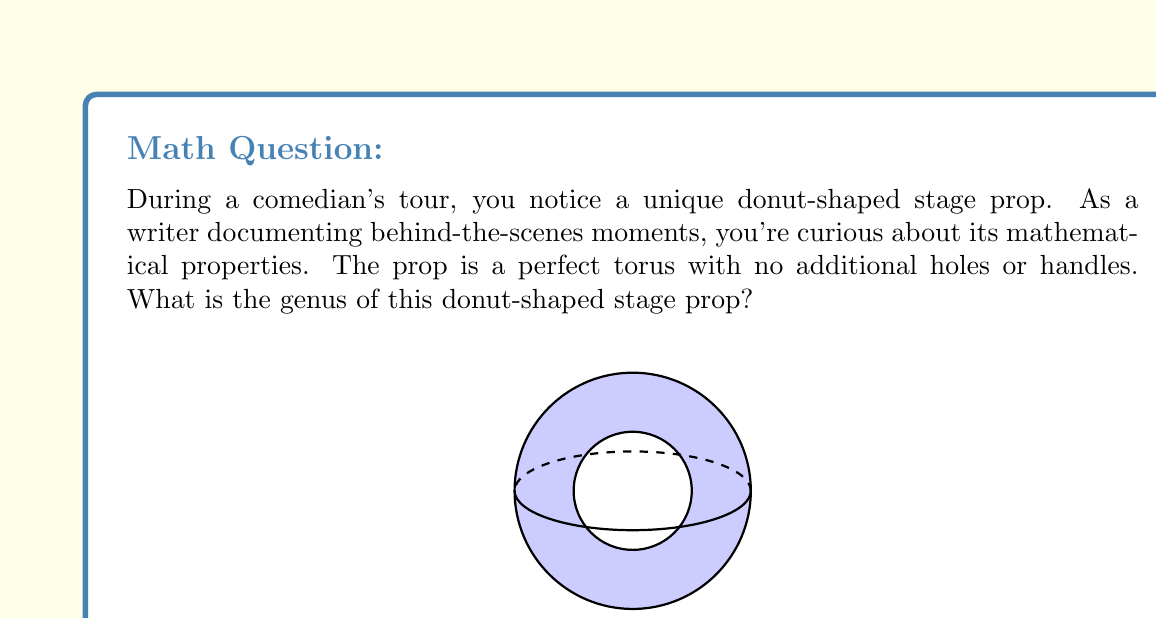Give your solution to this math problem. To determine the genus of the donut-shaped stage prop, we need to understand the concept of genus in topology and how it applies to a torus:

1. Definition: The genus of a surface is the maximum number of simple closed curves that can be drawn on the surface without separating it into distinct regions.

2. For a torus (donut shape):
   - It has one hole through its center.
   - We can draw two non-intersecting closed curves without separating the surface:
     a) One around the "tube" of the donut
     b) One through the central hole

3. Mathematical representation:
   - For a surface with $g$ holes, the genus is equal to $g$.
   - The equation for the genus of a connected, orientable surface is:
     $$ g = \frac{2 - \chi}{2} $$
     where $\chi$ is the Euler characteristic.

4. For a torus:
   - Euler characteristic $\chi = 0$
   - Plugging into the equation:
     $$ g = \frac{2 - 0}{2} = 1 $$

5. Verification:
   - This matches our intuitive understanding that a torus has one "hole" (through its center).

Therefore, the genus of the donut-shaped stage prop is 1.
Answer: 1 